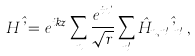Convert formula to latex. <formula><loc_0><loc_0><loc_500><loc_500>H \hat { \varphi } = e ^ { i k z } \sum _ { n } \frac { e ^ { i n \theta } } { \sqrt { r } } \sum _ { n ^ { \prime } } \hat { H } _ { n , n ^ { \prime } } \hat { \varphi } _ { n ^ { \prime } } \, ,</formula> 